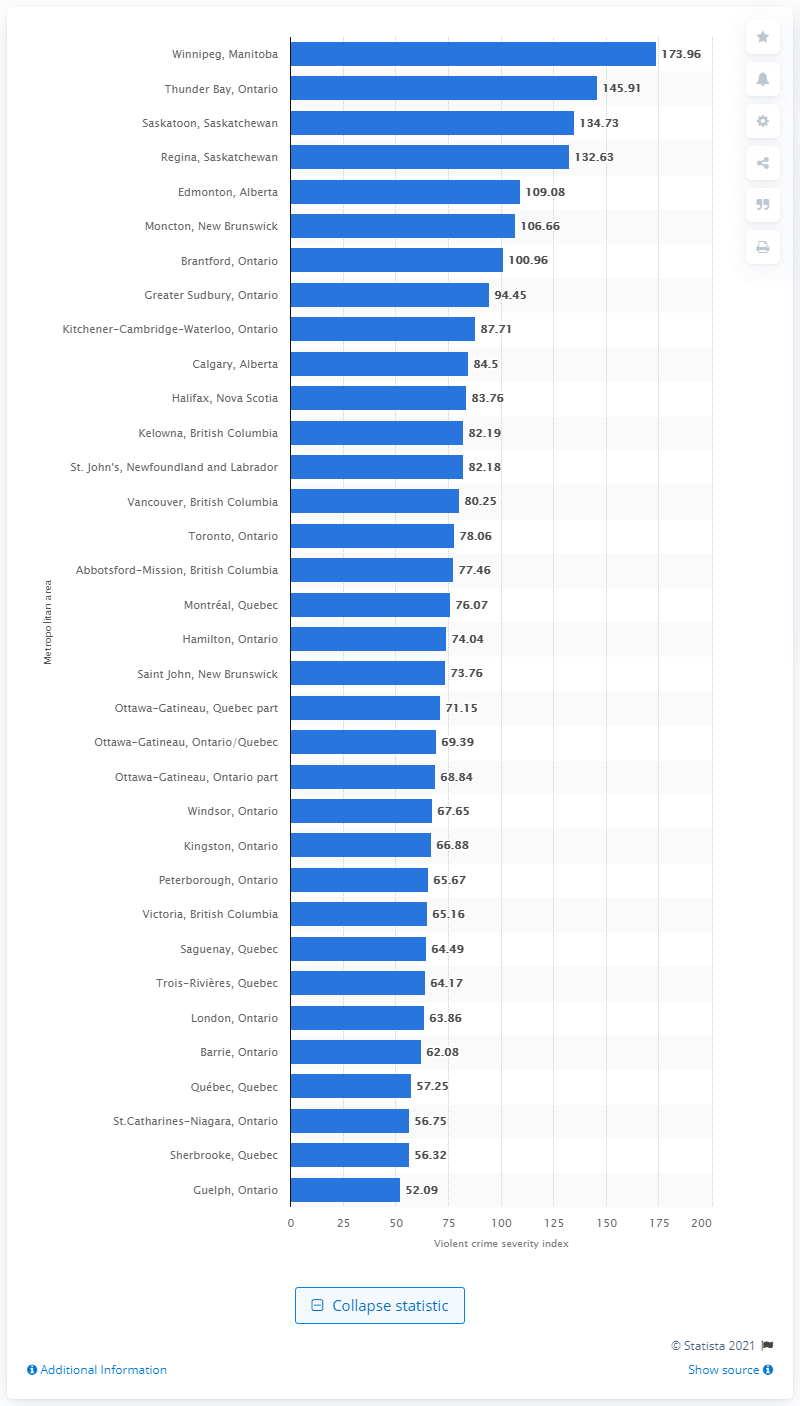Specify some key components in this picture. In 2019, the violent crime severity index for Winnipeg was 173.96. 